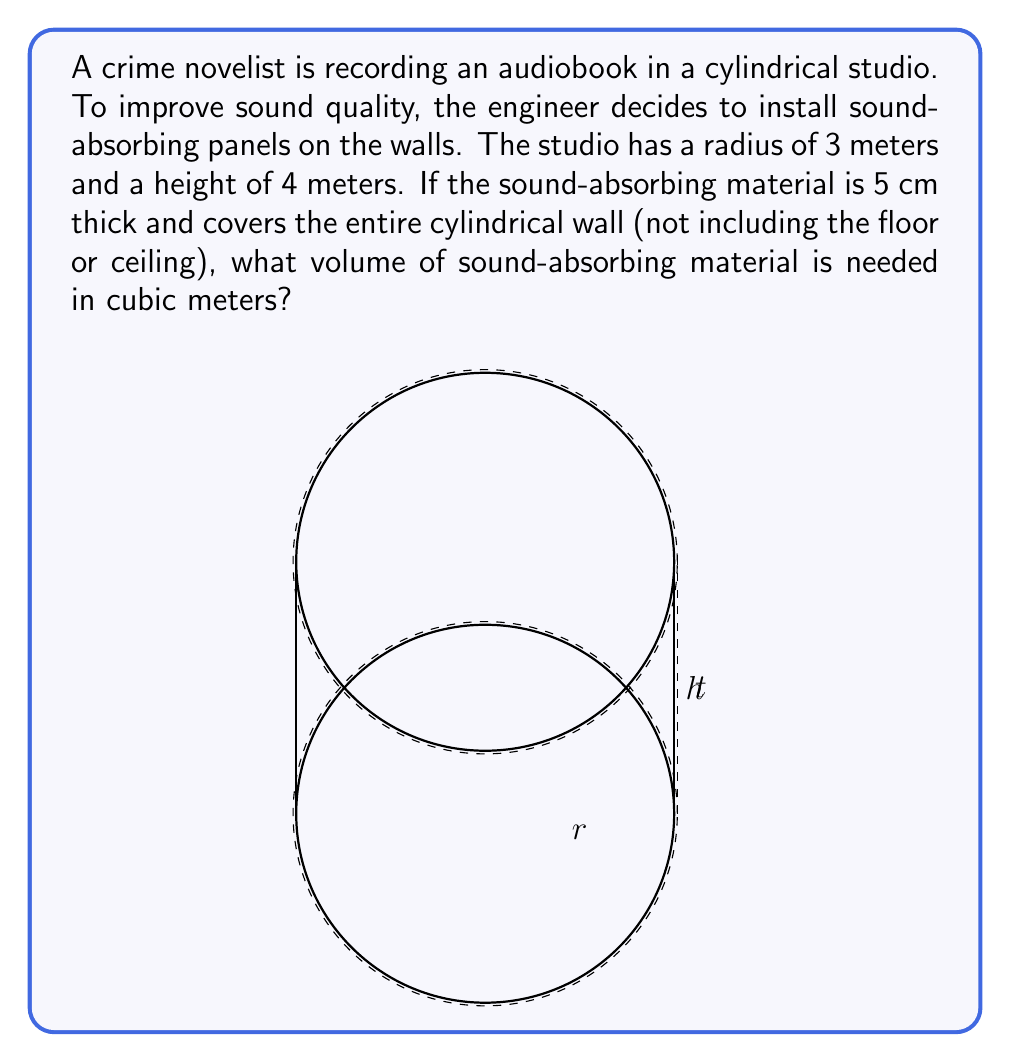Can you solve this math problem? To solve this problem, we need to calculate the volume of the cylindrical shell formed by the sound-absorbing material. We can do this by finding the difference between the volumes of two cylinders: the outer cylinder (including the material) and the inner cylinder (the studio itself).

Let's break it down step-by-step:

1) The volume of a cylinder is given by the formula $V = \pi r^2 h$, where $r$ is the radius and $h$ is the height.

2) For the inner cylinder (the studio):
   $r_1 = 3$ m
   $h = 4$ m
   $V_1 = \pi r_1^2 h = \pi (3^2) (4) = 36\pi$ m³

3) For the outer cylinder (including the sound-absorbing material):
   $r_2 = 3 + 0.05 = 3.05$ m (we add the thickness of the material)
   $h = 4$ m (height remains the same)
   $V_2 = \pi r_2^2 h = \pi (3.05^2) (4) = 37.21\pi$ m³

4) The volume of the sound-absorbing material is the difference between these two volumes:
   $V_{material} = V_2 - V_1 = 37.21\pi - 36\pi = 1.21\pi$ m³

5) To get the final answer in cubic meters, we calculate:
   $V_{material} = 1.21\pi \approx 3.8013$ m³

Thus, approximately 3.8013 cubic meters of sound-absorbing material is needed.
Answer: $$3.8013 \text{ m}^3$$ 